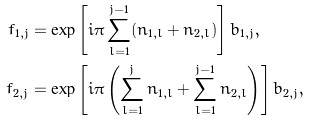<formula> <loc_0><loc_0><loc_500><loc_500>f _ { 1 , j } & = \exp \left [ i \pi \sum _ { l = 1 } ^ { j - 1 } ( n _ { 1 , l } + n _ { 2 , l } ) \right ] b _ { 1 , j } , \\ f _ { 2 , j } & = \exp \left [ i \pi \left ( \sum _ { l = 1 } ^ { j } n _ { 1 , l } + \sum _ { l = 1 } ^ { j - 1 } n _ { 2 , l } \right ) \right ] b _ { 2 , j } ,</formula> 